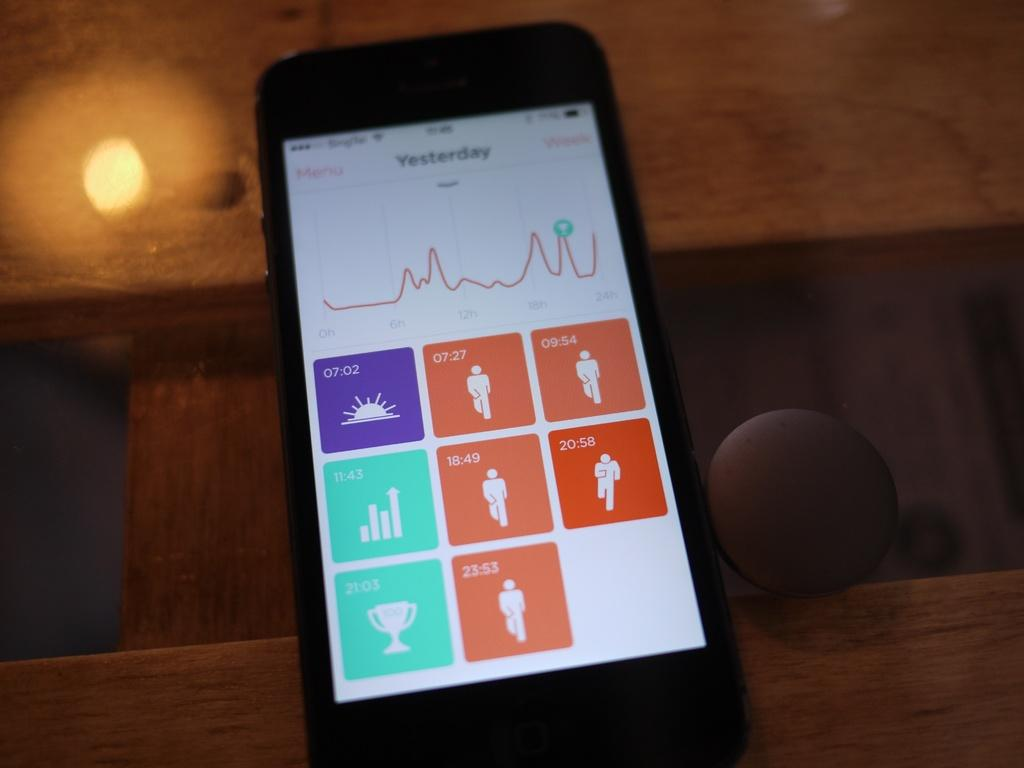<image>
Give a short and clear explanation of the subsequent image. A smartphone showing yesterday's fitness progress menu with connected to wifi. 